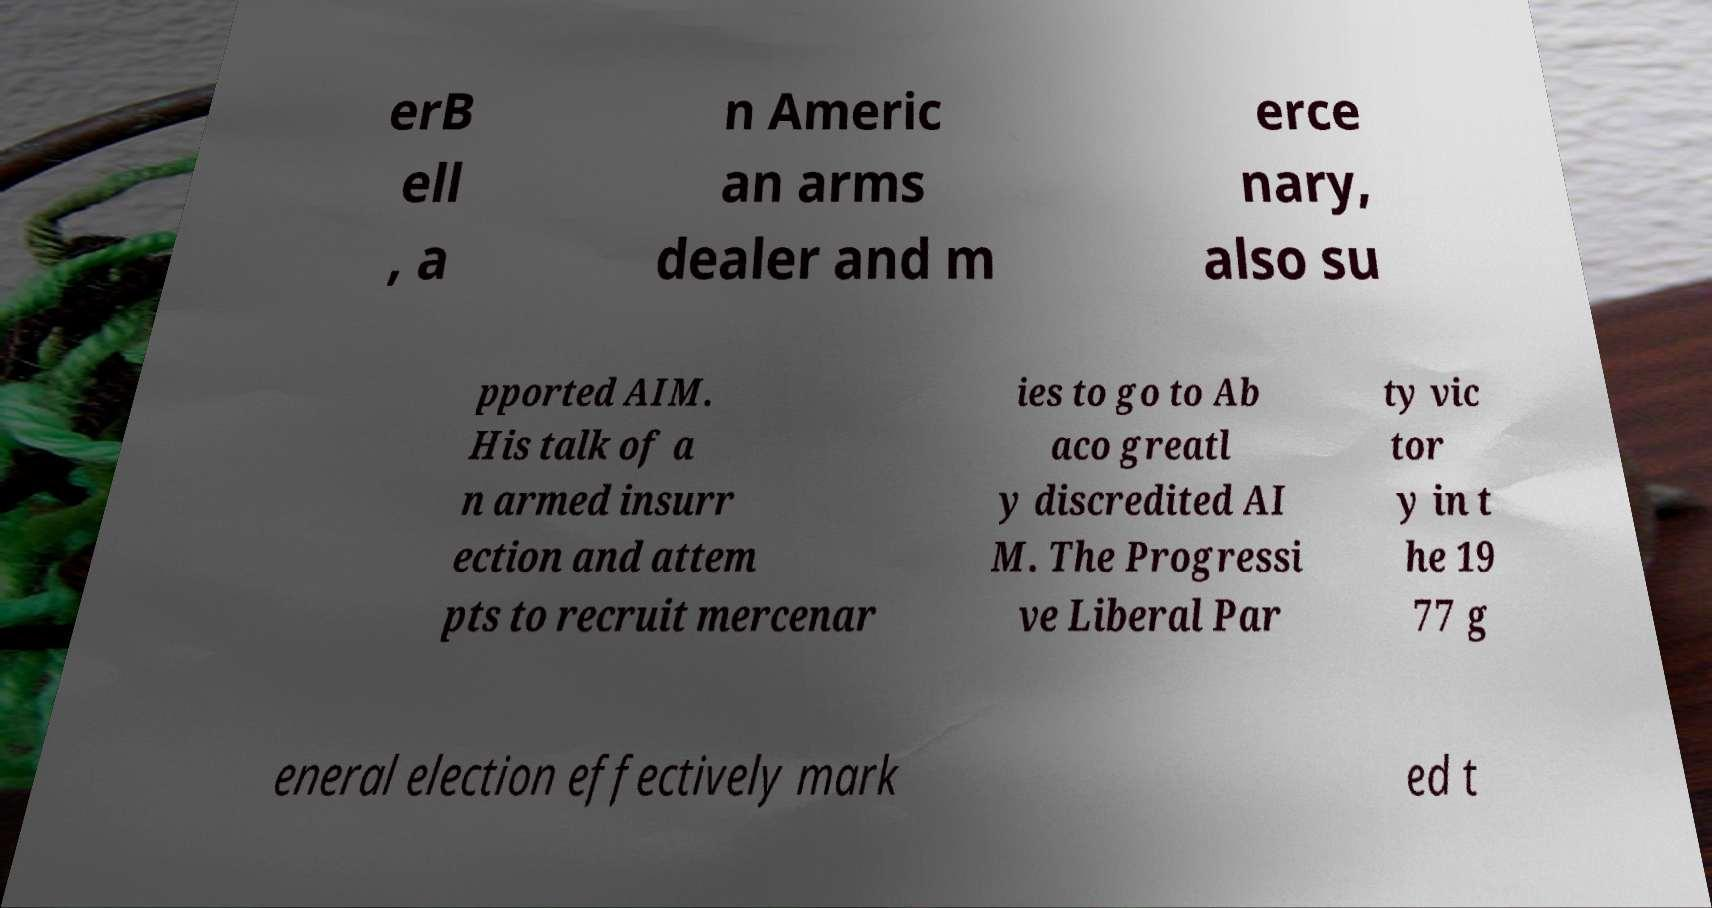There's text embedded in this image that I need extracted. Can you transcribe it verbatim? erB ell , a n Americ an arms dealer and m erce nary, also su pported AIM. His talk of a n armed insurr ection and attem pts to recruit mercenar ies to go to Ab aco greatl y discredited AI M. The Progressi ve Liberal Par ty vic tor y in t he 19 77 g eneral election effectively mark ed t 